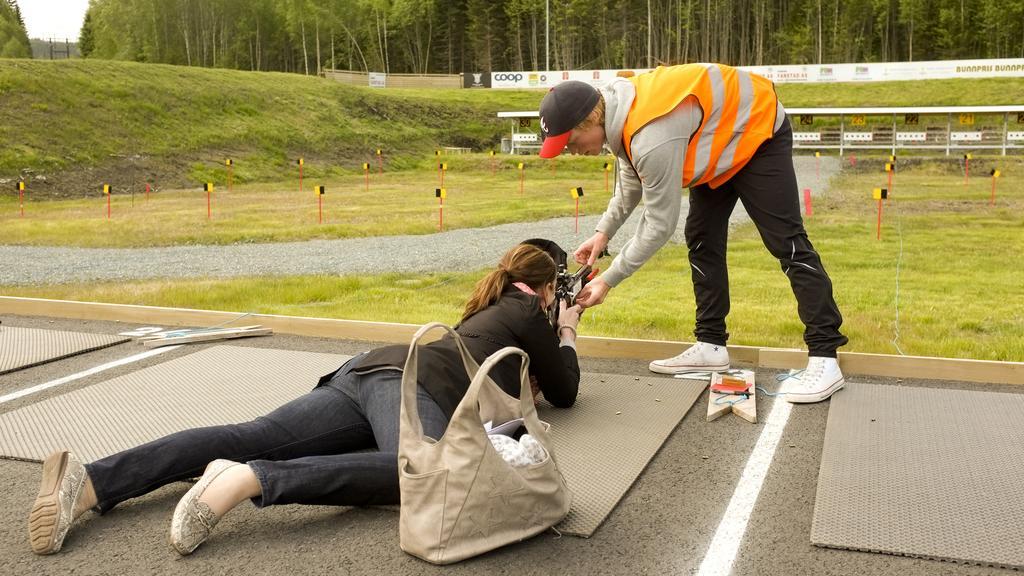Can you describe this image briefly? There is a women with black shirt and black jeans lying on the floor, this woman is holding the gun. There is a bag beside of the women. There is a man with red and black hat and white shoes standing right side of the woman holding the gun. There are trees at that back, there is grass at the right and left and there is sky at left top. 